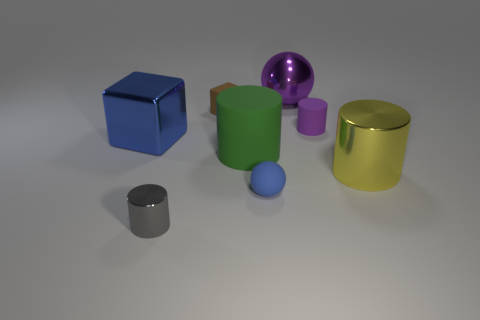Subtract 1 cylinders. How many cylinders are left? 3 Add 2 large purple metal objects. How many objects exist? 10 Subtract all blocks. How many objects are left? 6 Add 5 tiny metallic objects. How many tiny metallic objects are left? 6 Add 8 large blue metallic cubes. How many large blue metallic cubes exist? 9 Subtract 0 purple cubes. How many objects are left? 8 Subtract all tiny blue objects. Subtract all tiny rubber spheres. How many objects are left? 6 